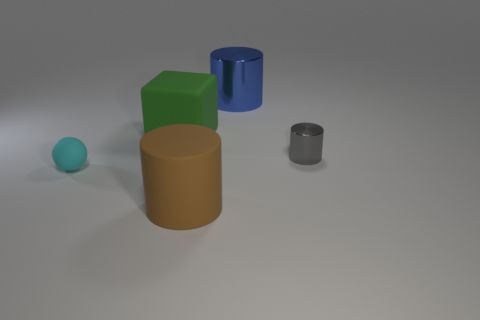Subtract all big cylinders. How many cylinders are left? 1 Add 3 brown metallic balls. How many objects exist? 8 Subtract all blue cylinders. How many cylinders are left? 2 Subtract all spheres. How many objects are left? 4 Subtract all cyan blocks. Subtract all gray cylinders. How many blocks are left? 1 Add 3 large green cubes. How many large green cubes are left? 4 Add 4 small red matte objects. How many small red matte objects exist? 4 Subtract 0 yellow blocks. How many objects are left? 5 Subtract all blue balls. How many brown cylinders are left? 1 Subtract all blue cylinders. Subtract all big green matte cubes. How many objects are left? 3 